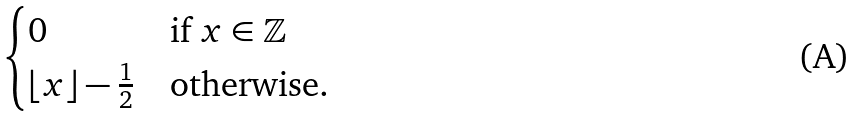Convert formula to latex. <formula><loc_0><loc_0><loc_500><loc_500>\begin{cases} 0 & \text {if } x \in \mathbb { Z } \\ \lfloor { x } \rfloor - \frac { 1 } { 2 } & \text {otherwise.} \end{cases}</formula> 